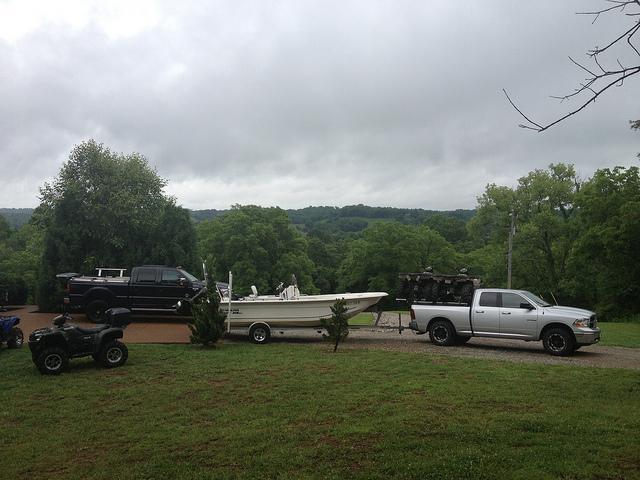What looks like it could happen any minute?
Pick the correct solution from the four options below to address the question.
Options: Tornado, sunshine, rain, fireworks. Rain. 